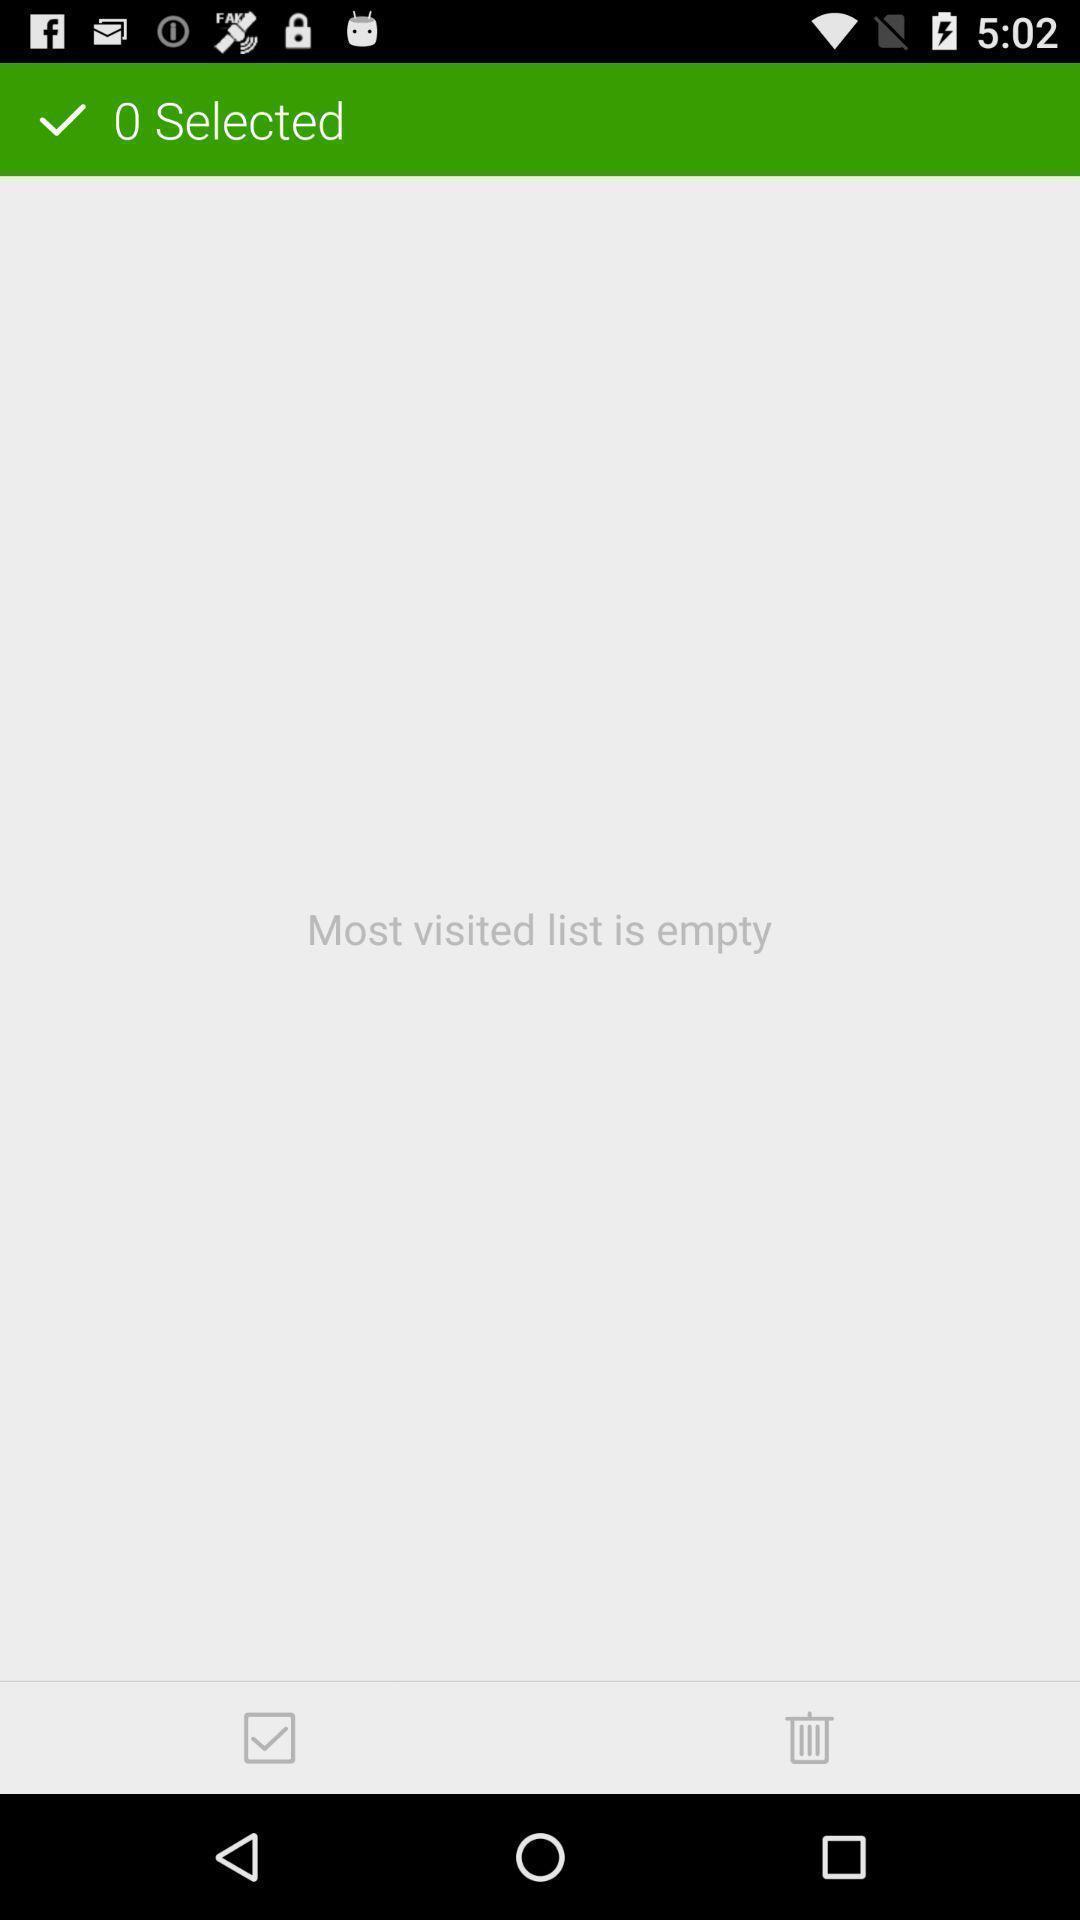Please provide a description for this image. Screen shows visited list is empty. 